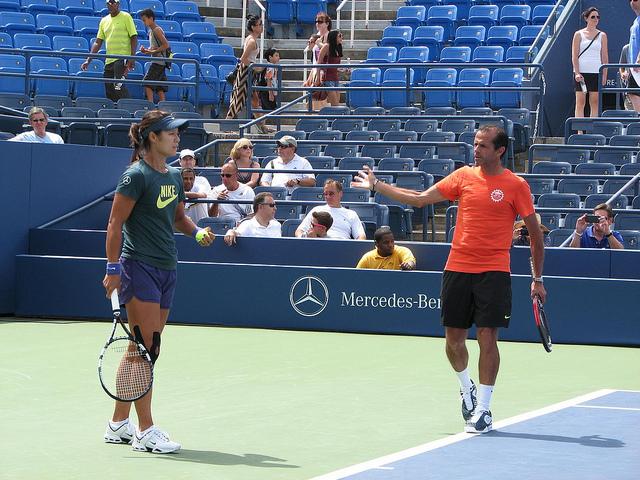What sport are they playing?
Concise answer only. Tennis. What color are the seats?
Answer briefly. Blue. Who is a sponsor?
Answer briefly. Mercedes-benz. 